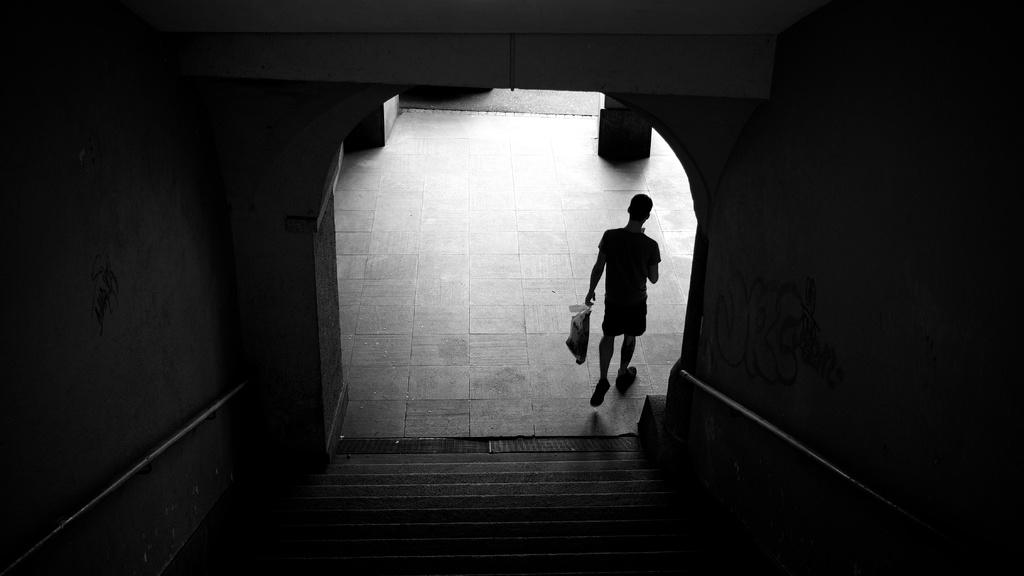What is located in the foreground of the image? There are stairs in the foreground of the image. What surrounds the stairs in the image? There are walls on either side of the stairs. What is the man in the background doing? In the background, there is a man holding a cover, and he is walking on the floor. How is the image presented in terms of color? The image is in black and white. How many planes are flying in the sky in the image? There are no planes visible in the image, as it is focused on the stairs, walls, and the man holding a cover. What type of stick is the man using to walk on the floor? There is no stick present in the image; the man is walking on the floor without any visible support. 